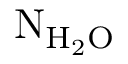<formula> <loc_0><loc_0><loc_500><loc_500>{ N _ { H _ { 2 } O } }</formula> 